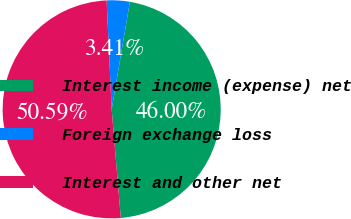<chart> <loc_0><loc_0><loc_500><loc_500><pie_chart><fcel>Interest income (expense) net<fcel>Foreign exchange loss<fcel>Interest and other net<nl><fcel>46.0%<fcel>3.41%<fcel>50.6%<nl></chart> 